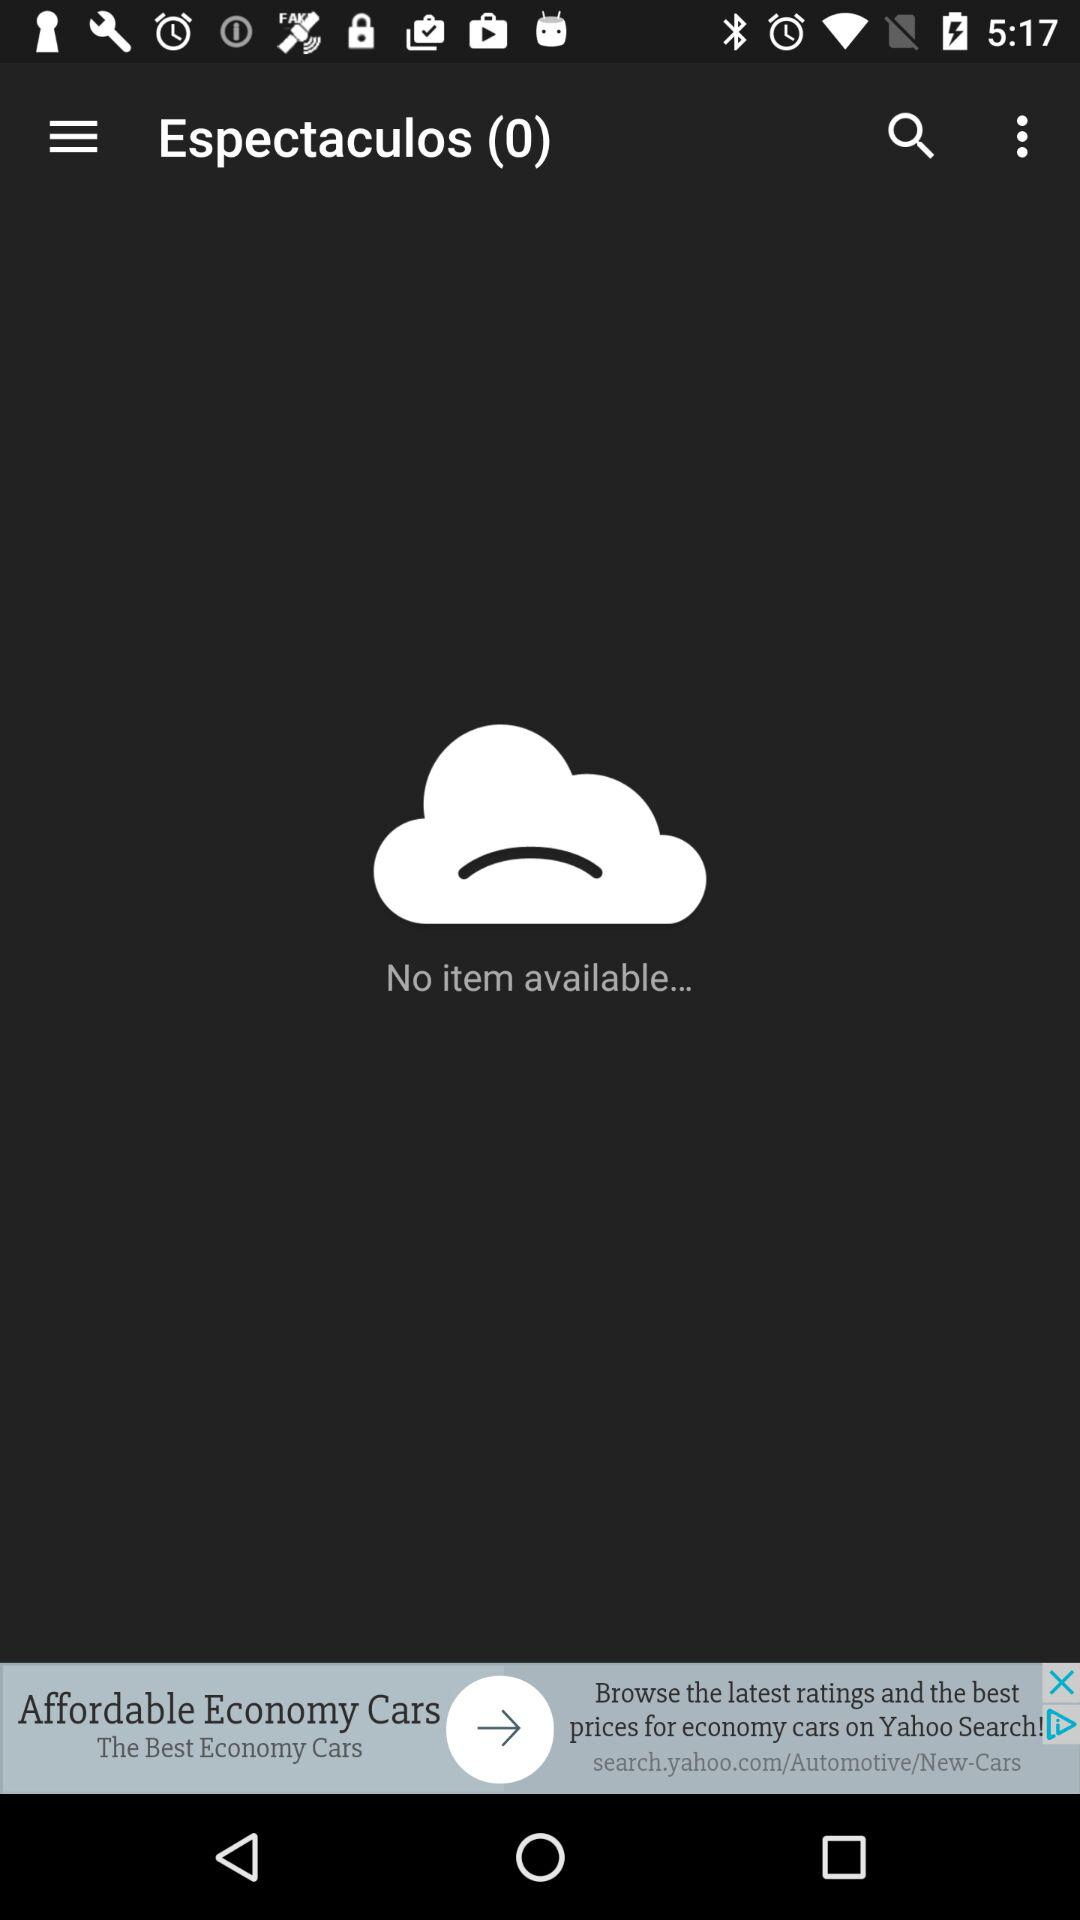How many items are available on the screen?
Answer the question using a single word or phrase. 0 